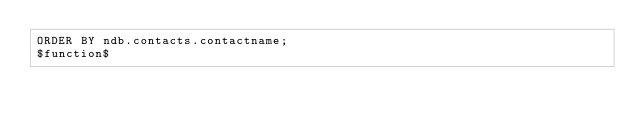<code> <loc_0><loc_0><loc_500><loc_500><_SQL_>ORDER BY ndb.contacts.contactname;
$function$
</code> 